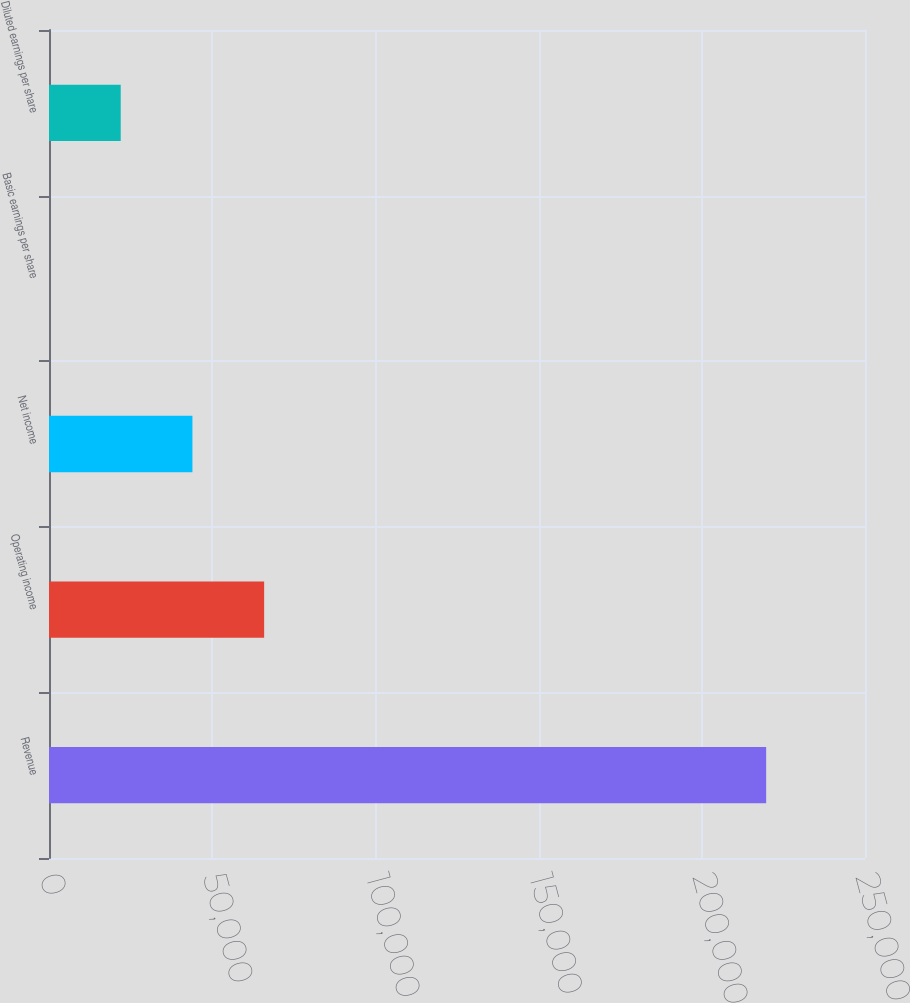Convert chart to OTSL. <chart><loc_0><loc_0><loc_500><loc_500><bar_chart><fcel>Revenue<fcel>Operating income<fcel>Net income<fcel>Basic earnings per share<fcel>Diluted earnings per share<nl><fcel>219719<fcel>65915.9<fcel>43944.1<fcel>0.33<fcel>21972.2<nl></chart> 